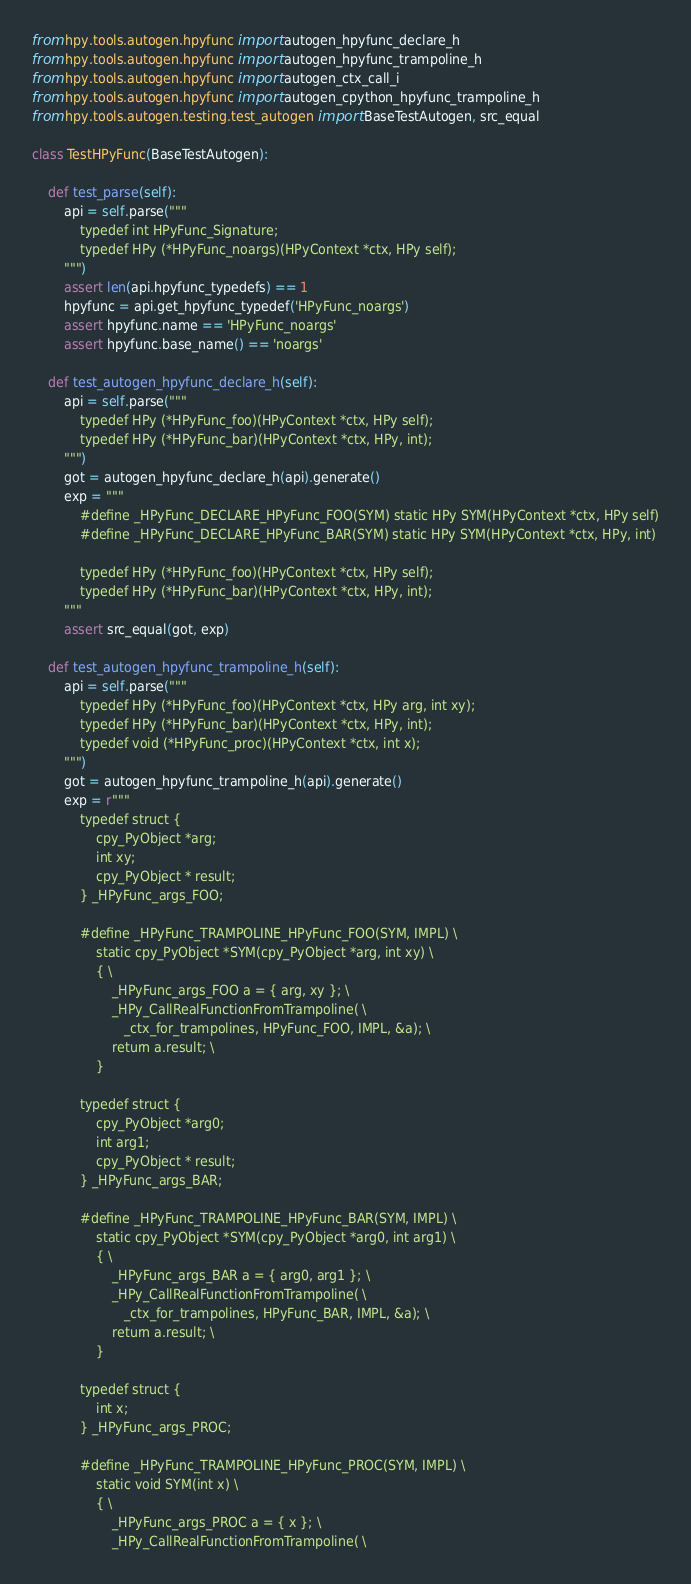Convert code to text. <code><loc_0><loc_0><loc_500><loc_500><_Python_>from hpy.tools.autogen.hpyfunc import autogen_hpyfunc_declare_h
from hpy.tools.autogen.hpyfunc import autogen_hpyfunc_trampoline_h
from hpy.tools.autogen.hpyfunc import autogen_ctx_call_i
from hpy.tools.autogen.hpyfunc import autogen_cpython_hpyfunc_trampoline_h
from hpy.tools.autogen.testing.test_autogen import BaseTestAutogen, src_equal

class TestHPyFunc(BaseTestAutogen):

    def test_parse(self):
        api = self.parse("""
            typedef int HPyFunc_Signature;
            typedef HPy (*HPyFunc_noargs)(HPyContext *ctx, HPy self);
        """)
        assert len(api.hpyfunc_typedefs) == 1
        hpyfunc = api.get_hpyfunc_typedef('HPyFunc_noargs')
        assert hpyfunc.name == 'HPyFunc_noargs'
        assert hpyfunc.base_name() == 'noargs'

    def test_autogen_hpyfunc_declare_h(self):
        api = self.parse("""
            typedef HPy (*HPyFunc_foo)(HPyContext *ctx, HPy self);
            typedef HPy (*HPyFunc_bar)(HPyContext *ctx, HPy, int);
        """)
        got = autogen_hpyfunc_declare_h(api).generate()
        exp = """
            #define _HPyFunc_DECLARE_HPyFunc_FOO(SYM) static HPy SYM(HPyContext *ctx, HPy self)
            #define _HPyFunc_DECLARE_HPyFunc_BAR(SYM) static HPy SYM(HPyContext *ctx, HPy, int)

            typedef HPy (*HPyFunc_foo)(HPyContext *ctx, HPy self);
            typedef HPy (*HPyFunc_bar)(HPyContext *ctx, HPy, int);
        """
        assert src_equal(got, exp)

    def test_autogen_hpyfunc_trampoline_h(self):
        api = self.parse("""
            typedef HPy (*HPyFunc_foo)(HPyContext *ctx, HPy arg, int xy);
            typedef HPy (*HPyFunc_bar)(HPyContext *ctx, HPy, int);
            typedef void (*HPyFunc_proc)(HPyContext *ctx, int x);
        """)
        got = autogen_hpyfunc_trampoline_h(api).generate()
        exp = r"""
            typedef struct {
                cpy_PyObject *arg;
                int xy;
                cpy_PyObject * result;
            } _HPyFunc_args_FOO;

            #define _HPyFunc_TRAMPOLINE_HPyFunc_FOO(SYM, IMPL) \
                static cpy_PyObject *SYM(cpy_PyObject *arg, int xy) \
                { \
                    _HPyFunc_args_FOO a = { arg, xy }; \
                    _HPy_CallRealFunctionFromTrampoline( \
                       _ctx_for_trampolines, HPyFunc_FOO, IMPL, &a); \
                    return a.result; \
                }

            typedef struct {
                cpy_PyObject *arg0;
                int arg1;
                cpy_PyObject * result;
            } _HPyFunc_args_BAR;

            #define _HPyFunc_TRAMPOLINE_HPyFunc_BAR(SYM, IMPL) \
                static cpy_PyObject *SYM(cpy_PyObject *arg0, int arg1) \
                { \
                    _HPyFunc_args_BAR a = { arg0, arg1 }; \
                    _HPy_CallRealFunctionFromTrampoline( \
                       _ctx_for_trampolines, HPyFunc_BAR, IMPL, &a); \
                    return a.result; \
                }

            typedef struct {
                int x;
            } _HPyFunc_args_PROC;

            #define _HPyFunc_TRAMPOLINE_HPyFunc_PROC(SYM, IMPL) \
                static void SYM(int x) \
                { \
                    _HPyFunc_args_PROC a = { x }; \
                    _HPy_CallRealFunctionFromTrampoline( \</code> 